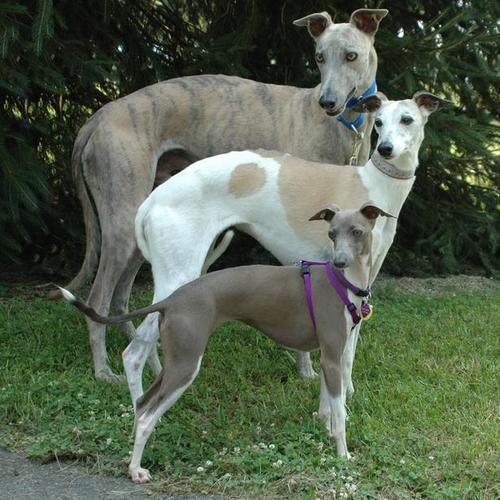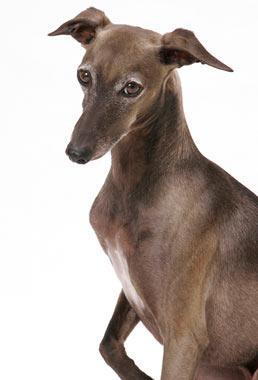The first image is the image on the left, the second image is the image on the right. Assess this claim about the two images: "Left image contains more than one dog, with at least one wearing a collar.". Correct or not? Answer yes or no. Yes. The first image is the image on the left, the second image is the image on the right. Assess this claim about the two images: "A dog is sitting on a cloth.". Correct or not? Answer yes or no. No. 